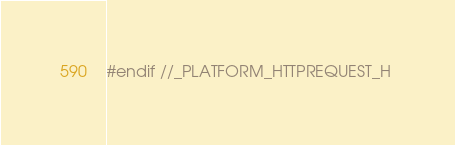<code> <loc_0><loc_0><loc_500><loc_500><_C_>
#endif //_PLATFORM_HTTPREQUEST_H 
</code> 